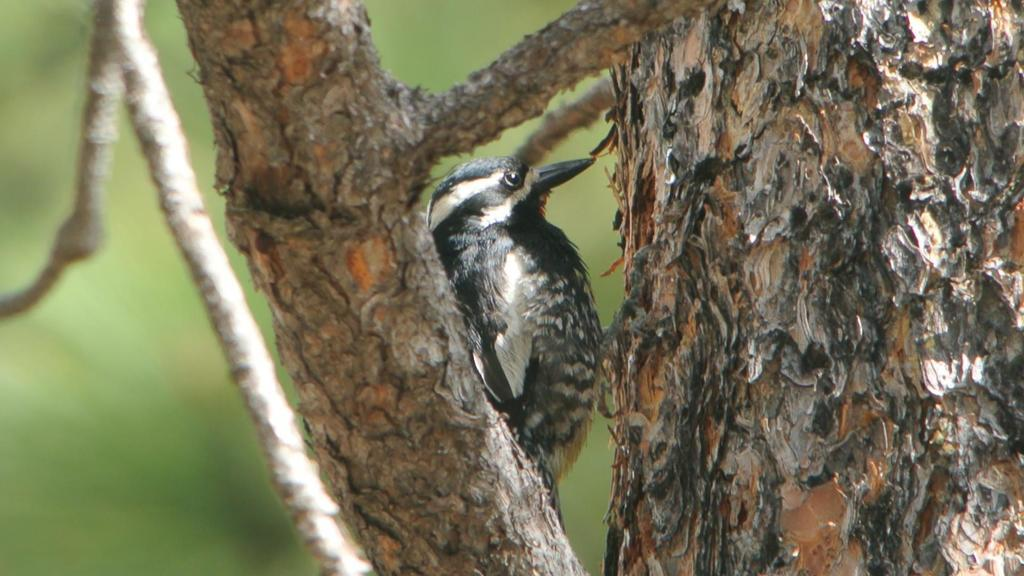What type of animal is in the image? There is a bird in the image. Where is the bird located in relation to other objects in the image? The bird is near a tree. In which direction is the bird looking? The bird is looking in a particular direction. What type of print can be seen on the toys in the image? There are no toys present in the image, so it is not possible to determine the type of print on any toys. 